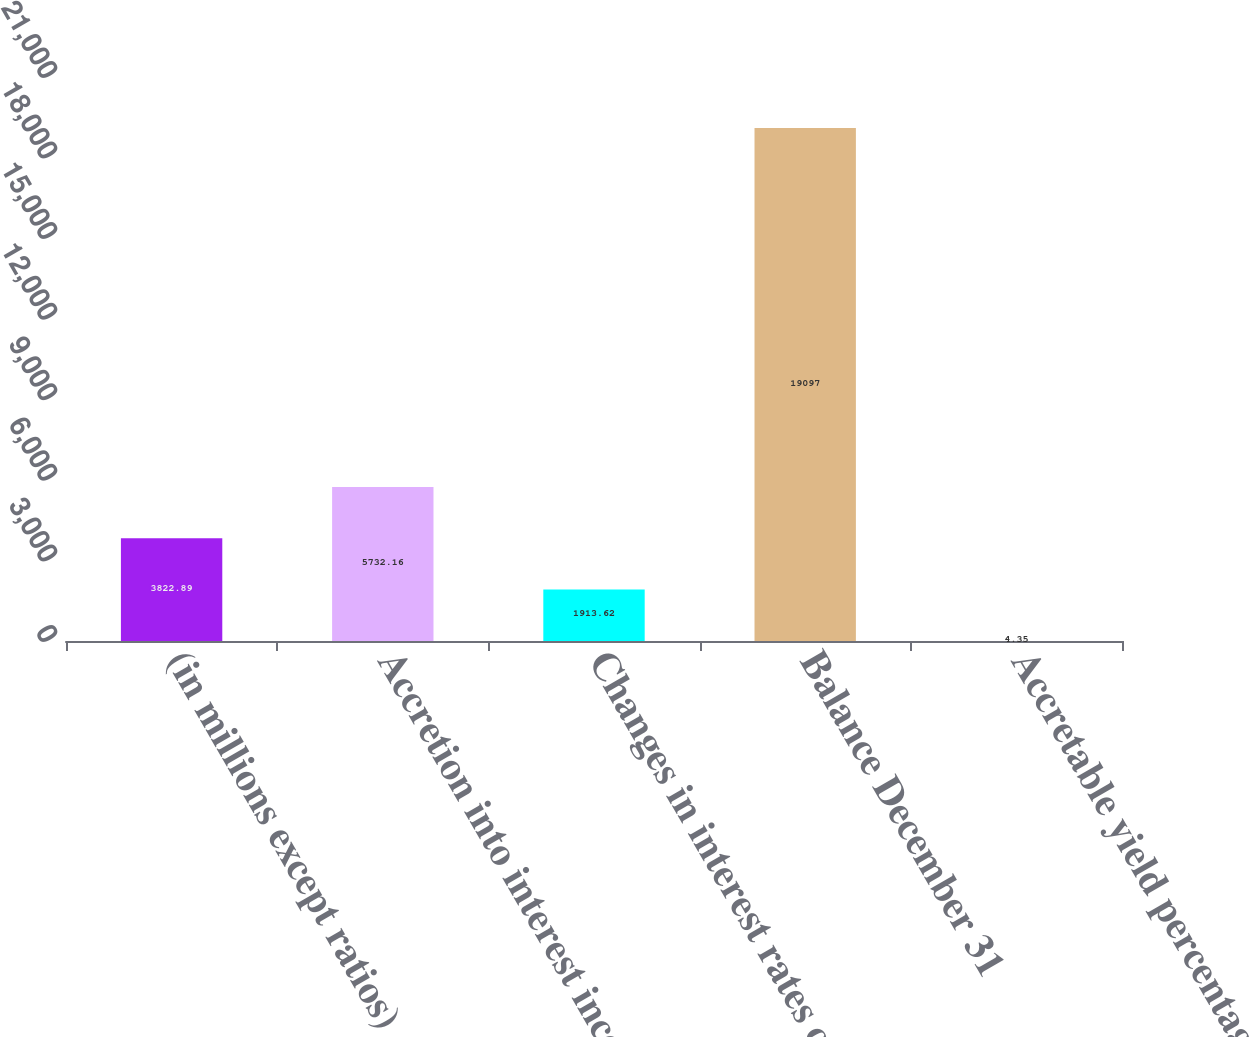<chart> <loc_0><loc_0><loc_500><loc_500><bar_chart><fcel>(in millions except ratios)<fcel>Accretion into interest income<fcel>Changes in interest rates on<fcel>Balance December 31<fcel>Accretable yield percentage<nl><fcel>3822.89<fcel>5732.16<fcel>1913.62<fcel>19097<fcel>4.35<nl></chart> 